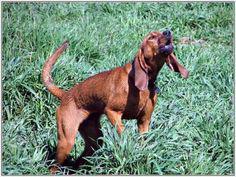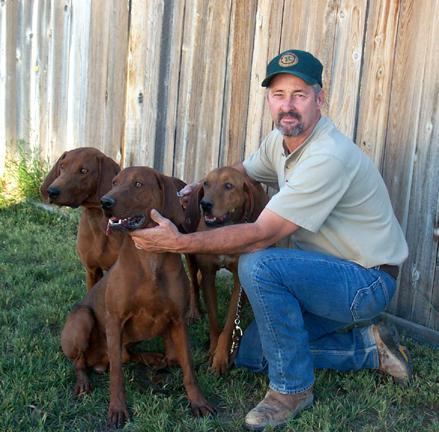The first image is the image on the left, the second image is the image on the right. For the images shown, is this caption "At least three dogs are visible." true? Answer yes or no. Yes. The first image is the image on the left, the second image is the image on the right. Considering the images on both sides, is "At least two dogs with upright heads and shoulders are near a pair of legs in blue jeans." valid? Answer yes or no. Yes. 